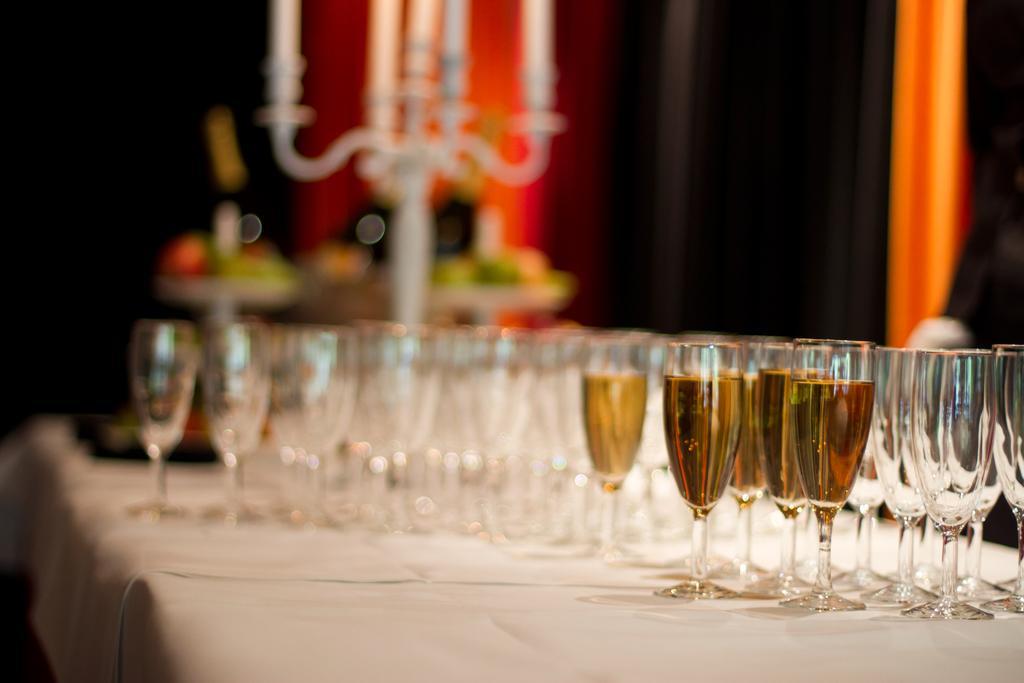Could you give a brief overview of what you see in this image? In this image there are some glasses of wine and some empty glasses on the table ,and in the background there are candles with the candles stand and there are some other objects. 